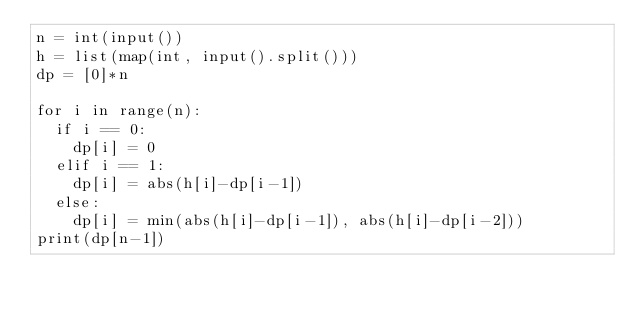Convert code to text. <code><loc_0><loc_0><loc_500><loc_500><_Python_>n = int(input())
h = list(map(int, input().split()))
dp = [0]*n

for i in range(n):
  if i == 0:
    dp[i] = 0
  elif i == 1:
    dp[i] = abs(h[i]-dp[i-1])
  else:
    dp[i] = min(abs(h[i]-dp[i-1]), abs(h[i]-dp[i-2]))
print(dp[n-1])
</code> 